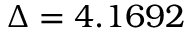Convert formula to latex. <formula><loc_0><loc_0><loc_500><loc_500>\Delta = 4 . 1 6 9 2</formula> 